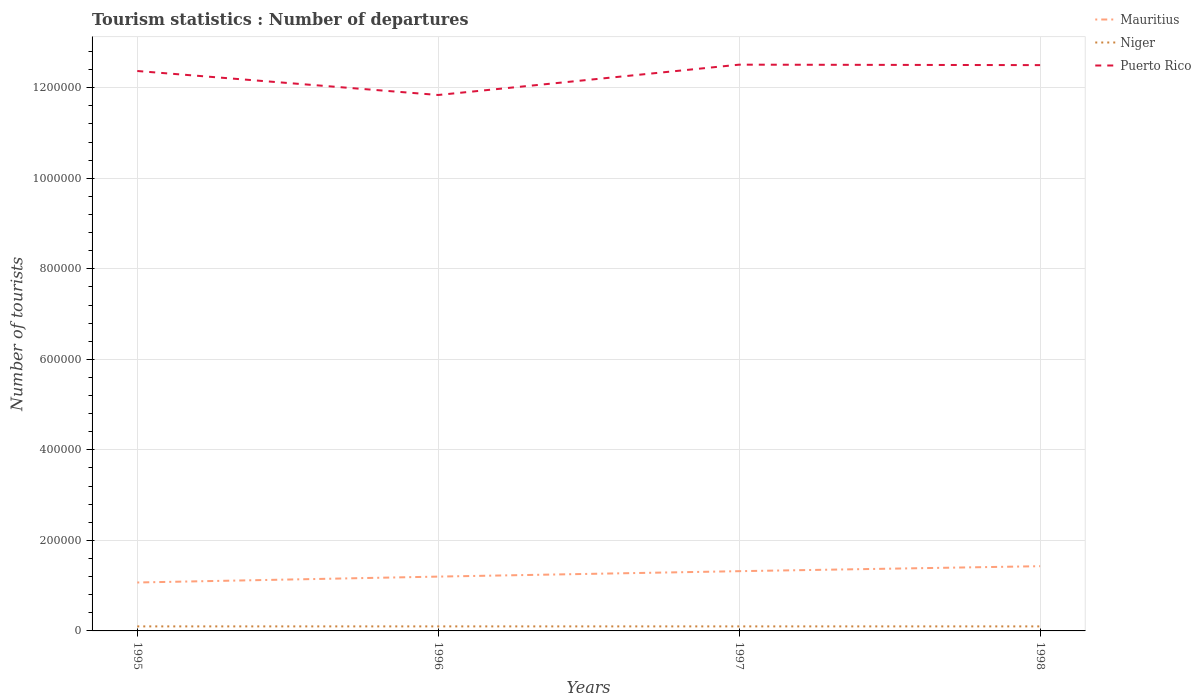Does the line corresponding to Niger intersect with the line corresponding to Puerto Rico?
Give a very brief answer. No. Across all years, what is the maximum number of tourist departures in Mauritius?
Offer a very short reply. 1.07e+05. In which year was the number of tourist departures in Puerto Rico maximum?
Provide a short and direct response. 1996. What is the total number of tourist departures in Puerto Rico in the graph?
Provide a succinct answer. 5.30e+04. What is the difference between the highest and the second highest number of tourist departures in Puerto Rico?
Offer a very short reply. 6.70e+04. How many lines are there?
Your response must be concise. 3. How many years are there in the graph?
Keep it short and to the point. 4. What is the difference between two consecutive major ticks on the Y-axis?
Ensure brevity in your answer.  2.00e+05. Are the values on the major ticks of Y-axis written in scientific E-notation?
Offer a terse response. No. Does the graph contain any zero values?
Your answer should be compact. No. Does the graph contain grids?
Offer a terse response. Yes. Where does the legend appear in the graph?
Offer a very short reply. Top right. What is the title of the graph?
Your answer should be very brief. Tourism statistics : Number of departures. What is the label or title of the X-axis?
Offer a very short reply. Years. What is the label or title of the Y-axis?
Provide a short and direct response. Number of tourists. What is the Number of tourists in Mauritius in 1995?
Give a very brief answer. 1.07e+05. What is the Number of tourists of Niger in 1995?
Give a very brief answer. 10000. What is the Number of tourists in Puerto Rico in 1995?
Make the answer very short. 1.24e+06. What is the Number of tourists of Puerto Rico in 1996?
Provide a succinct answer. 1.18e+06. What is the Number of tourists of Mauritius in 1997?
Your answer should be compact. 1.32e+05. What is the Number of tourists of Puerto Rico in 1997?
Your answer should be very brief. 1.25e+06. What is the Number of tourists of Mauritius in 1998?
Give a very brief answer. 1.43e+05. What is the Number of tourists of Puerto Rico in 1998?
Provide a succinct answer. 1.25e+06. Across all years, what is the maximum Number of tourists of Mauritius?
Ensure brevity in your answer.  1.43e+05. Across all years, what is the maximum Number of tourists in Niger?
Your response must be concise. 10000. Across all years, what is the maximum Number of tourists in Puerto Rico?
Make the answer very short. 1.25e+06. Across all years, what is the minimum Number of tourists in Mauritius?
Offer a terse response. 1.07e+05. Across all years, what is the minimum Number of tourists in Niger?
Make the answer very short. 10000. Across all years, what is the minimum Number of tourists of Puerto Rico?
Keep it short and to the point. 1.18e+06. What is the total Number of tourists in Mauritius in the graph?
Keep it short and to the point. 5.02e+05. What is the total Number of tourists of Niger in the graph?
Give a very brief answer. 4.00e+04. What is the total Number of tourists in Puerto Rico in the graph?
Your answer should be compact. 4.92e+06. What is the difference between the Number of tourists of Mauritius in 1995 and that in 1996?
Offer a very short reply. -1.30e+04. What is the difference between the Number of tourists of Puerto Rico in 1995 and that in 1996?
Your answer should be very brief. 5.30e+04. What is the difference between the Number of tourists of Mauritius in 1995 and that in 1997?
Make the answer very short. -2.50e+04. What is the difference between the Number of tourists of Niger in 1995 and that in 1997?
Offer a terse response. 0. What is the difference between the Number of tourists of Puerto Rico in 1995 and that in 1997?
Offer a very short reply. -1.40e+04. What is the difference between the Number of tourists of Mauritius in 1995 and that in 1998?
Your response must be concise. -3.60e+04. What is the difference between the Number of tourists of Niger in 1995 and that in 1998?
Offer a terse response. 0. What is the difference between the Number of tourists in Puerto Rico in 1995 and that in 1998?
Provide a succinct answer. -1.30e+04. What is the difference between the Number of tourists of Mauritius in 1996 and that in 1997?
Provide a short and direct response. -1.20e+04. What is the difference between the Number of tourists in Niger in 1996 and that in 1997?
Provide a short and direct response. 0. What is the difference between the Number of tourists in Puerto Rico in 1996 and that in 1997?
Ensure brevity in your answer.  -6.70e+04. What is the difference between the Number of tourists in Mauritius in 1996 and that in 1998?
Your answer should be very brief. -2.30e+04. What is the difference between the Number of tourists in Niger in 1996 and that in 1998?
Keep it short and to the point. 0. What is the difference between the Number of tourists of Puerto Rico in 1996 and that in 1998?
Provide a succinct answer. -6.60e+04. What is the difference between the Number of tourists in Mauritius in 1997 and that in 1998?
Offer a terse response. -1.10e+04. What is the difference between the Number of tourists in Puerto Rico in 1997 and that in 1998?
Offer a very short reply. 1000. What is the difference between the Number of tourists of Mauritius in 1995 and the Number of tourists of Niger in 1996?
Your response must be concise. 9.70e+04. What is the difference between the Number of tourists of Mauritius in 1995 and the Number of tourists of Puerto Rico in 1996?
Your answer should be compact. -1.08e+06. What is the difference between the Number of tourists in Niger in 1995 and the Number of tourists in Puerto Rico in 1996?
Provide a succinct answer. -1.17e+06. What is the difference between the Number of tourists in Mauritius in 1995 and the Number of tourists in Niger in 1997?
Offer a very short reply. 9.70e+04. What is the difference between the Number of tourists of Mauritius in 1995 and the Number of tourists of Puerto Rico in 1997?
Give a very brief answer. -1.14e+06. What is the difference between the Number of tourists of Niger in 1995 and the Number of tourists of Puerto Rico in 1997?
Provide a succinct answer. -1.24e+06. What is the difference between the Number of tourists of Mauritius in 1995 and the Number of tourists of Niger in 1998?
Offer a terse response. 9.70e+04. What is the difference between the Number of tourists of Mauritius in 1995 and the Number of tourists of Puerto Rico in 1998?
Make the answer very short. -1.14e+06. What is the difference between the Number of tourists of Niger in 1995 and the Number of tourists of Puerto Rico in 1998?
Keep it short and to the point. -1.24e+06. What is the difference between the Number of tourists of Mauritius in 1996 and the Number of tourists of Puerto Rico in 1997?
Give a very brief answer. -1.13e+06. What is the difference between the Number of tourists of Niger in 1996 and the Number of tourists of Puerto Rico in 1997?
Give a very brief answer. -1.24e+06. What is the difference between the Number of tourists in Mauritius in 1996 and the Number of tourists in Puerto Rico in 1998?
Your response must be concise. -1.13e+06. What is the difference between the Number of tourists of Niger in 1996 and the Number of tourists of Puerto Rico in 1998?
Provide a succinct answer. -1.24e+06. What is the difference between the Number of tourists in Mauritius in 1997 and the Number of tourists in Niger in 1998?
Your response must be concise. 1.22e+05. What is the difference between the Number of tourists in Mauritius in 1997 and the Number of tourists in Puerto Rico in 1998?
Provide a short and direct response. -1.12e+06. What is the difference between the Number of tourists in Niger in 1997 and the Number of tourists in Puerto Rico in 1998?
Provide a succinct answer. -1.24e+06. What is the average Number of tourists of Mauritius per year?
Keep it short and to the point. 1.26e+05. What is the average Number of tourists in Puerto Rico per year?
Give a very brief answer. 1.23e+06. In the year 1995, what is the difference between the Number of tourists of Mauritius and Number of tourists of Niger?
Offer a terse response. 9.70e+04. In the year 1995, what is the difference between the Number of tourists in Mauritius and Number of tourists in Puerto Rico?
Provide a short and direct response. -1.13e+06. In the year 1995, what is the difference between the Number of tourists of Niger and Number of tourists of Puerto Rico?
Your answer should be very brief. -1.23e+06. In the year 1996, what is the difference between the Number of tourists in Mauritius and Number of tourists in Niger?
Give a very brief answer. 1.10e+05. In the year 1996, what is the difference between the Number of tourists of Mauritius and Number of tourists of Puerto Rico?
Give a very brief answer. -1.06e+06. In the year 1996, what is the difference between the Number of tourists in Niger and Number of tourists in Puerto Rico?
Give a very brief answer. -1.17e+06. In the year 1997, what is the difference between the Number of tourists of Mauritius and Number of tourists of Niger?
Keep it short and to the point. 1.22e+05. In the year 1997, what is the difference between the Number of tourists in Mauritius and Number of tourists in Puerto Rico?
Make the answer very short. -1.12e+06. In the year 1997, what is the difference between the Number of tourists in Niger and Number of tourists in Puerto Rico?
Offer a very short reply. -1.24e+06. In the year 1998, what is the difference between the Number of tourists in Mauritius and Number of tourists in Niger?
Give a very brief answer. 1.33e+05. In the year 1998, what is the difference between the Number of tourists of Mauritius and Number of tourists of Puerto Rico?
Keep it short and to the point. -1.11e+06. In the year 1998, what is the difference between the Number of tourists in Niger and Number of tourists in Puerto Rico?
Your response must be concise. -1.24e+06. What is the ratio of the Number of tourists in Mauritius in 1995 to that in 1996?
Offer a terse response. 0.89. What is the ratio of the Number of tourists of Niger in 1995 to that in 1996?
Your answer should be compact. 1. What is the ratio of the Number of tourists in Puerto Rico in 1995 to that in 1996?
Ensure brevity in your answer.  1.04. What is the ratio of the Number of tourists of Mauritius in 1995 to that in 1997?
Your answer should be very brief. 0.81. What is the ratio of the Number of tourists in Niger in 1995 to that in 1997?
Your answer should be very brief. 1. What is the ratio of the Number of tourists in Mauritius in 1995 to that in 1998?
Provide a succinct answer. 0.75. What is the ratio of the Number of tourists in Niger in 1995 to that in 1998?
Provide a short and direct response. 1. What is the ratio of the Number of tourists of Puerto Rico in 1995 to that in 1998?
Provide a short and direct response. 0.99. What is the ratio of the Number of tourists of Mauritius in 1996 to that in 1997?
Your response must be concise. 0.91. What is the ratio of the Number of tourists of Niger in 1996 to that in 1997?
Make the answer very short. 1. What is the ratio of the Number of tourists in Puerto Rico in 1996 to that in 1997?
Keep it short and to the point. 0.95. What is the ratio of the Number of tourists of Mauritius in 1996 to that in 1998?
Offer a very short reply. 0.84. What is the ratio of the Number of tourists in Niger in 1996 to that in 1998?
Offer a terse response. 1. What is the ratio of the Number of tourists in Puerto Rico in 1996 to that in 1998?
Your answer should be very brief. 0.95. What is the ratio of the Number of tourists of Mauritius in 1997 to that in 1998?
Give a very brief answer. 0.92. What is the ratio of the Number of tourists of Niger in 1997 to that in 1998?
Provide a short and direct response. 1. What is the ratio of the Number of tourists of Puerto Rico in 1997 to that in 1998?
Provide a succinct answer. 1. What is the difference between the highest and the second highest Number of tourists of Mauritius?
Offer a very short reply. 1.10e+04. What is the difference between the highest and the lowest Number of tourists in Mauritius?
Give a very brief answer. 3.60e+04. What is the difference between the highest and the lowest Number of tourists of Puerto Rico?
Provide a succinct answer. 6.70e+04. 